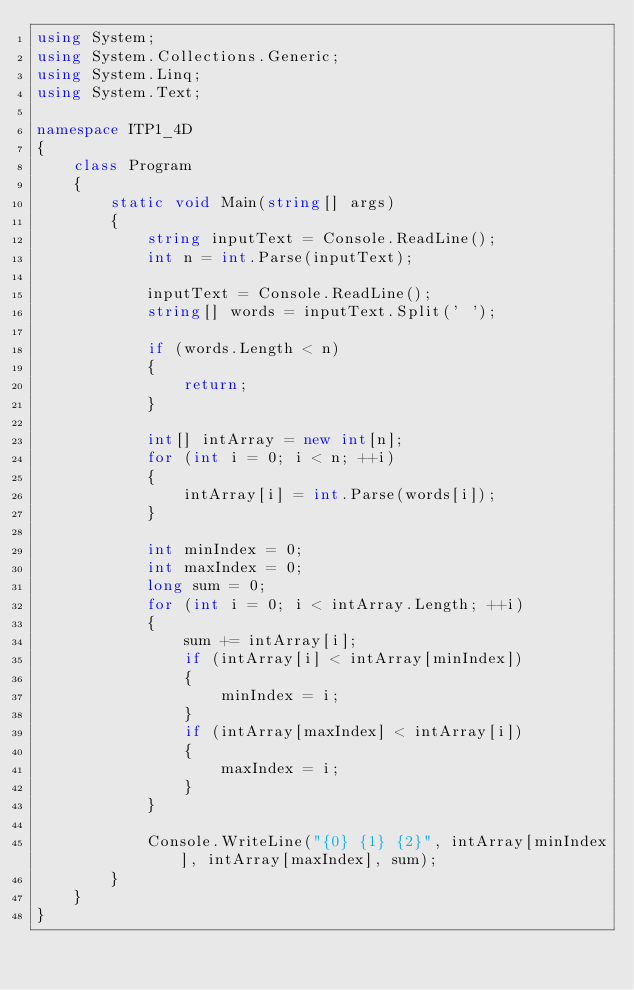Convert code to text. <code><loc_0><loc_0><loc_500><loc_500><_C#_>using System;
using System.Collections.Generic;
using System.Linq;
using System.Text;
 
namespace ITP1_4D
{
    class Program
    {
        static void Main(string[] args)
        {
            string inputText = Console.ReadLine();
            int n = int.Parse(inputText);
 
            inputText = Console.ReadLine();
            string[] words = inputText.Split(' ');
 
            if (words.Length < n)
            {
                return;
            }
 
            int[] intArray = new int[n];
            for (int i = 0; i < n; ++i)
            {
                intArray[i] = int.Parse(words[i]);
            }
 
            int minIndex = 0;
            int maxIndex = 0;
            long sum = 0;
            for (int i = 0; i < intArray.Length; ++i)
            {
                sum += intArray[i];
                if (intArray[i] < intArray[minIndex])
                {
                    minIndex = i;
                }
                if (intArray[maxIndex] < intArray[i])
                {
                    maxIndex = i;
                }
            }
 
            Console.WriteLine("{0} {1} {2}", intArray[minIndex], intArray[maxIndex], sum);
        }
    }
}</code> 